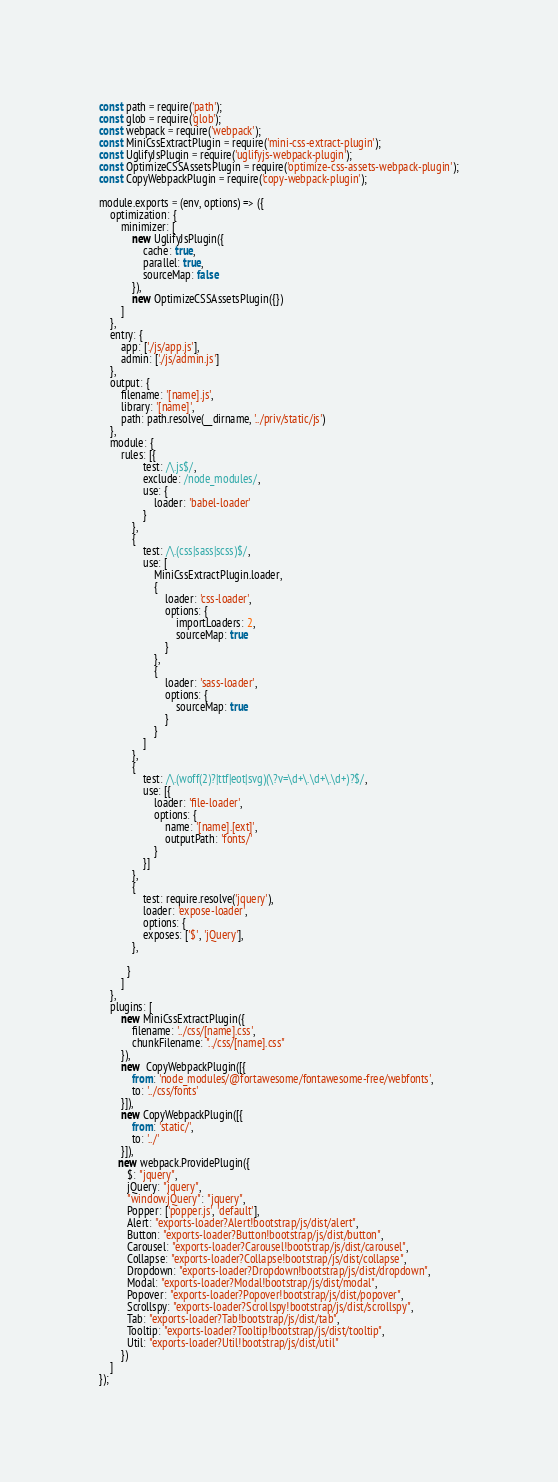<code> <loc_0><loc_0><loc_500><loc_500><_JavaScript_>const path = require('path');
const glob = require('glob');
const webpack = require('webpack');
const MiniCssExtractPlugin = require('mini-css-extract-plugin');
const UglifyJsPlugin = require('uglifyjs-webpack-plugin');
const OptimizeCSSAssetsPlugin = require('optimize-css-assets-webpack-plugin');
const CopyWebpackPlugin = require('copy-webpack-plugin');

module.exports = (env, options) => ({
    optimization: {
        minimizer: [
            new UglifyJsPlugin({
                cache: true,
                parallel: true,
                sourceMap: false
            }),
            new OptimizeCSSAssetsPlugin({})
        ]
    },
    entry: {
        app: ['./js/app.js'],
        admin: ['./js/admin.js']
    },
    output: {
        filename: '[name].js',
        library: '[name]',
        path: path.resolve(__dirname, '../priv/static/js')
    },
    module: {
        rules: [{
                test: /\.js$/,
                exclude: /node_modules/,
                use: {
                    loader: 'babel-loader'
                }
            },
            {
                test: /\.(css|sass|scss)$/,
                use: [
                    MiniCssExtractPlugin.loader,
                    {
                        loader: 'css-loader',
                        options: {
                            importLoaders: 2,
                            sourceMap: true
                        }
                    },
                    {
                        loader: 'sass-loader',
                        options: {
                            sourceMap: true
                        }
                    }
                ]
            },
            {
                test: /\.(woff(2)?|ttf|eot|svg)(\?v=\d+\.\d+\.\d+)?$/,
                use: [{
                    loader: 'file-loader',
                    options: {
                        name: '[name].[ext]',
                        outputPath: 'fonts/'
                    }
                }]
            },
            {
                test: require.resolve('jquery'),
                loader: 'expose-loader',
                options: {
                exposes: ['$', 'jQuery'],
            },

          }
        ]
    },
    plugins: [
        new MiniCssExtractPlugin({
            filename: '../css/[name].css',
            chunkFilename: "../css/[name].css"
        }),
        new  CopyWebpackPlugin([{
            from: 'node_modules/@fortawesome/fontawesome-free/webfonts',
            to: '../css/fonts'
        }]), 
        new CopyWebpackPlugin([{
            from: 'static/',
            to: '../'
        }]),
       new webpack.ProvidePlugin({
          $: "jquery",
          jQuery: "jquery",
          "window.jQuery": "jquery",
          Popper: ['popper.js', 'default'],
          Alert: "exports-loader?Alert!bootstrap/js/dist/alert",
          Button: "exports-loader?Button!bootstrap/js/dist/button",
          Carousel: "exports-loader?Carousel!bootstrap/js/dist/carousel",
          Collapse: "exports-loader?Collapse!bootstrap/js/dist/collapse",
          Dropdown: "exports-loader?Dropdown!bootstrap/js/dist/dropdown",
          Modal: "exports-loader?Modal!bootstrap/js/dist/modal",
          Popover: "exports-loader?Popover!bootstrap/js/dist/popover",
          Scrollspy: "exports-loader?Scrollspy!bootstrap/js/dist/scrollspy",
          Tab: "exports-loader?Tab!bootstrap/js/dist/tab",
          Tooltip: "exports-loader?Tooltip!bootstrap/js/dist/tooltip",
          Util: "exports-loader?Util!bootstrap/js/dist/util"
        })
    ]
});
</code> 